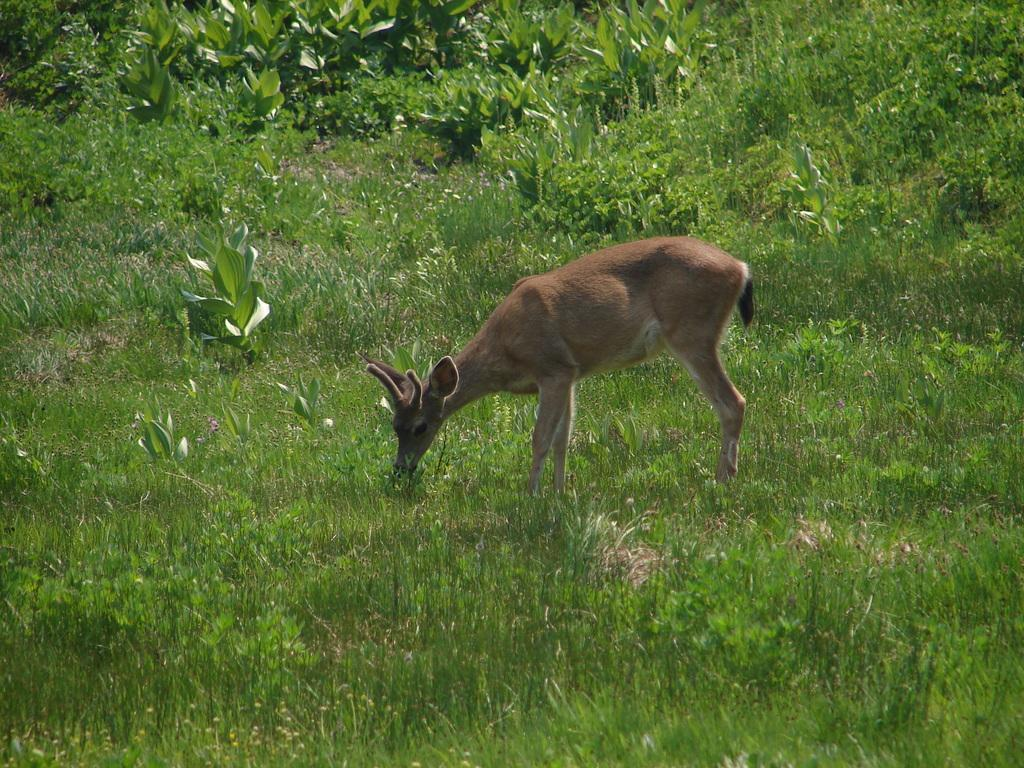What animal is present in the image? There is a deer in the image. Where is the deer located? The deer is on the ground. What can be seen in the background of the image? There are plants visible in the background of the image. How many ladybugs are sitting on the button of the vessel in the image? There are no ladybugs, buttons, or vessels present in the image. 